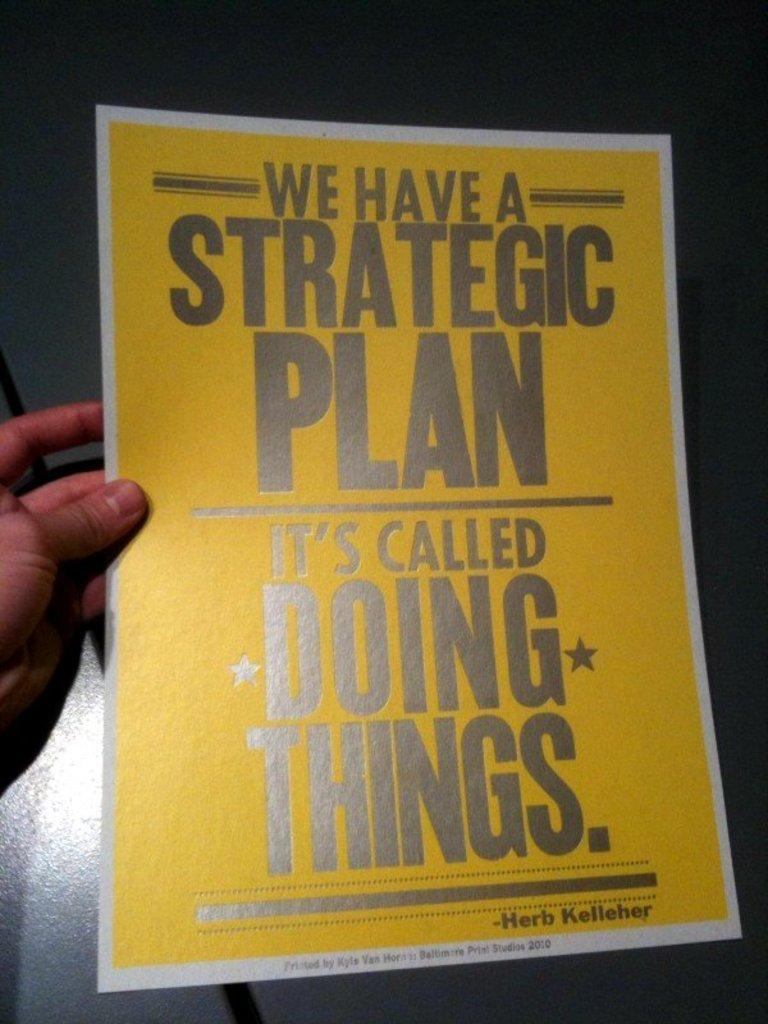<image>
Share a concise interpretation of the image provided. Person holding a sign that says "It's Called Doing Things.". 